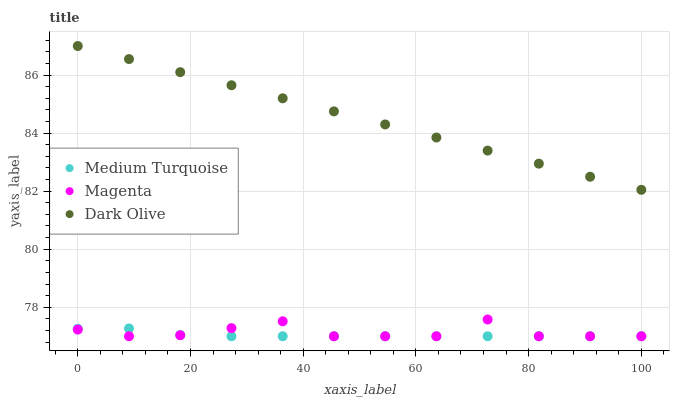Does Medium Turquoise have the minimum area under the curve?
Answer yes or no. Yes. Does Dark Olive have the maximum area under the curve?
Answer yes or no. Yes. Does Dark Olive have the minimum area under the curve?
Answer yes or no. No. Does Medium Turquoise have the maximum area under the curve?
Answer yes or no. No. Is Dark Olive the smoothest?
Answer yes or no. Yes. Is Magenta the roughest?
Answer yes or no. Yes. Is Medium Turquoise the smoothest?
Answer yes or no. No. Is Medium Turquoise the roughest?
Answer yes or no. No. Does Magenta have the lowest value?
Answer yes or no. Yes. Does Dark Olive have the lowest value?
Answer yes or no. No. Does Dark Olive have the highest value?
Answer yes or no. Yes. Does Medium Turquoise have the highest value?
Answer yes or no. No. Is Magenta less than Dark Olive?
Answer yes or no. Yes. Is Dark Olive greater than Magenta?
Answer yes or no. Yes. Does Medium Turquoise intersect Magenta?
Answer yes or no. Yes. Is Medium Turquoise less than Magenta?
Answer yes or no. No. Is Medium Turquoise greater than Magenta?
Answer yes or no. No. Does Magenta intersect Dark Olive?
Answer yes or no. No. 